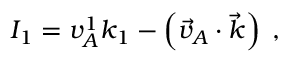<formula> <loc_0><loc_0><loc_500><loc_500>I _ { 1 } = v _ { A } ^ { 1 } k _ { 1 } - \left ( \vec { v } _ { A } \cdot \vec { k } \right ) \, ,</formula> 